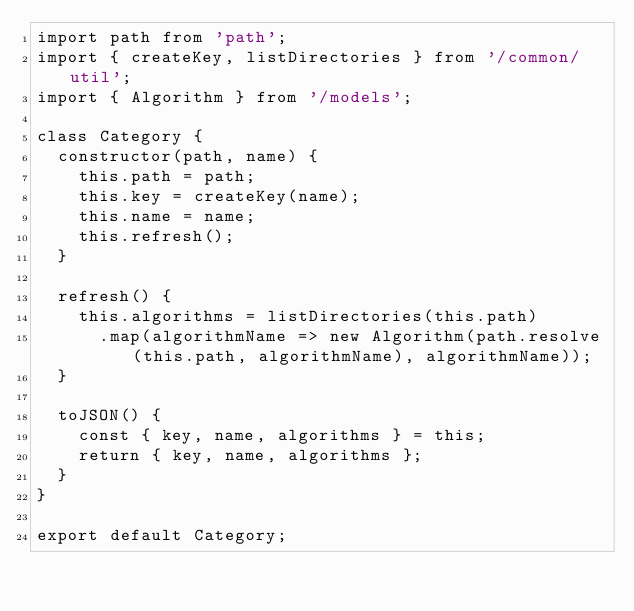Convert code to text. <code><loc_0><loc_0><loc_500><loc_500><_JavaScript_>import path from 'path';
import { createKey, listDirectories } from '/common/util';
import { Algorithm } from '/models';

class Category {
  constructor(path, name) {
    this.path = path;
    this.key = createKey(name);
    this.name = name;
    this.refresh();
  }

  refresh() {
    this.algorithms = listDirectories(this.path)
      .map(algorithmName => new Algorithm(path.resolve(this.path, algorithmName), algorithmName));
  }

  toJSON() {
    const { key, name, algorithms } = this;
    return { key, name, algorithms };
  }
}

export default Category;
</code> 